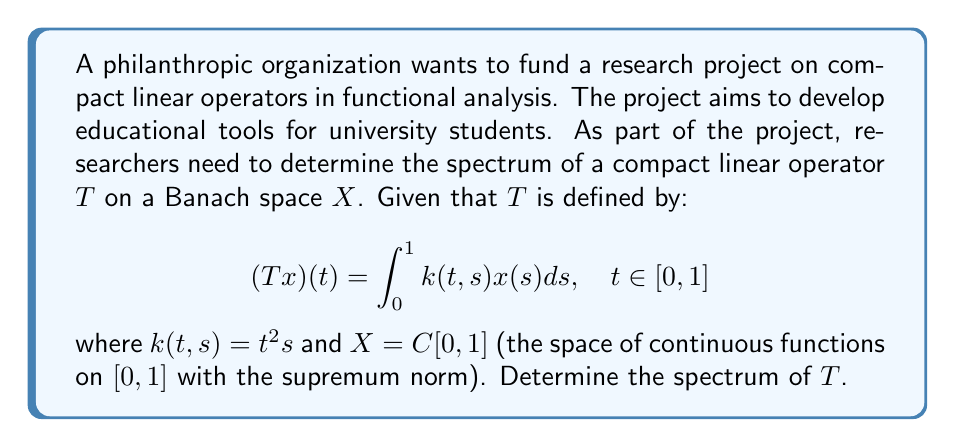Could you help me with this problem? To determine the spectrum of the compact linear operator $T$, we'll follow these steps:

1) First, recall that for a compact operator on an infinite-dimensional Banach space, the spectrum consists of 0 and the eigenvalues of $T$, with 0 being the only possible accumulation point.

2) To find the eigenvalues, we need to solve the equation:

   $$Tx = \lambda x$$

   for non-zero $x \in X$ and $\lambda \in \mathbb{C}$.

3) Expanding this equation using the definition of $T$:

   $$\int_0^1 t^2sx(s)ds = \lambda x(t)$$

4) Differentiating both sides twice with respect to $t$:

   $$\frac{d^2}{dt^2}\left(\int_0^1 t^2sx(s)ds\right) = \lambda \frac{d^2x(t)}{dt^2}$$

   $$2\int_0^1 sx(s)ds = \lambda \frac{d^2x(t)}{dt^2}$$

5) The left-hand side is a constant. Let's call it $c = 2\int_0^1 sx(s)ds$. Then:

   $$c = \lambda \frac{d^2x(t)}{dt^2}$$

6) The general solution to this differential equation is:

   $$x(t) = At^2 + Bt + C$$

   where $A = \frac{c}{2\lambda}$, and $B$ and $C$ are arbitrary constants.

7) Substituting this solution back into the original equation:

   $$\int_0^1 t^2s(As^2 + Bs + C)ds = \lambda(At^2 + Bt + C)$$

8) Evaluating the integral and equating coefficients:

   $$A\frac{t^2}{20} + B\frac{t^2}{12} + C\frac{t^2}{3} = \lambda At^2 + \lambda Bt + \lambda C$$

9) Equating coefficients of $t^2$, $t$, and the constant terms:

   $$\frac{A}{20} + \frac{B}{12} + \frac{C}{3} = \lambda A$$
   $$0 = \lambda B$$
   $$0 = \lambda C$$

10) From the last two equations, we see that if $\lambda \neq 0$, then $B = C = 0$. Substituting this into the first equation:

    $$\frac{A}{20} = \lambda A$$

11) If $A \neq 0$ (which must be true for a non-zero eigenfunction), then:

    $$\lambda = \frac{1}{20}$$

Therefore, the only non-zero eigenvalue is $\frac{1}{20}$.
Answer: The spectrum of $T$ is $\{0, \frac{1}{20}\}$. 